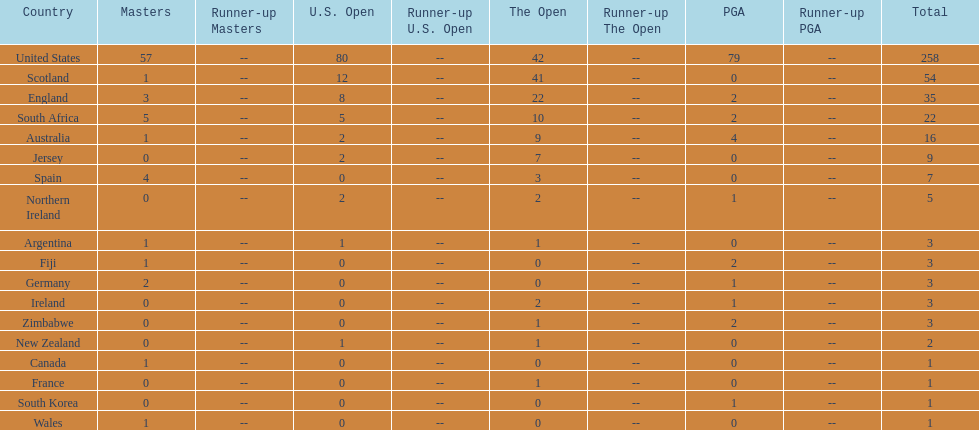How many countries have produced the same number of championship golfers as canada? 3. 